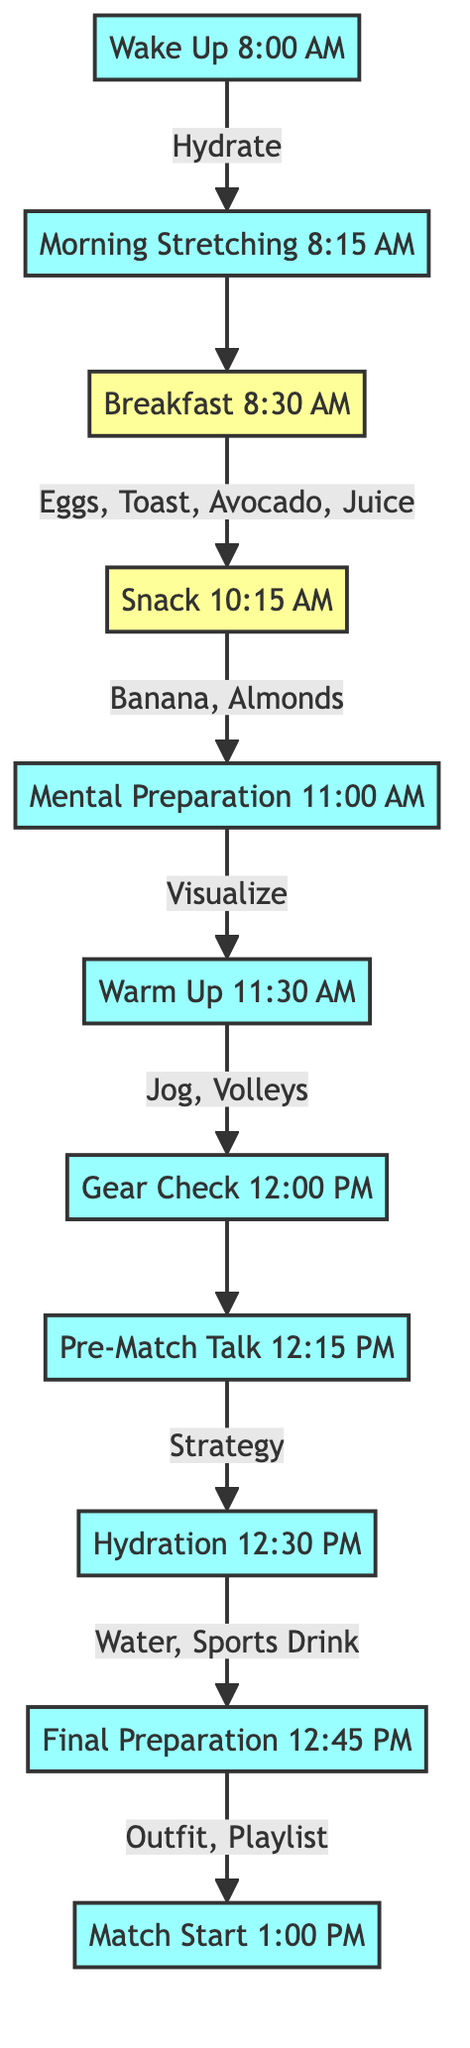What time does the final preparation start? The diagram indicates that the final preparation occurs at 12:45 PM after the hydration step at 12:30 PM.
Answer: 12:45 PM What action is performed at 11:00 AM? The diagram shows that at 11:00 AM, the action is mental preparation, which involves visualization of match scenarios and positive outcomes.
Answer: Mental Preparation How many nutrition components are listed in breakfast? To find this, I look at the breakfast node which lists four components: scrambled eggs, whole grain toast, avocado, and fresh orange juice. Therefore, the count is four.
Answer: 4 What comes after the warm-up action? Following the warm-up at 11:30 AM, the next action listed is the gear check, which starts at 12:00 PM.
Answer: Gear Check What are the components of the snack? In the diagram, the snack at 10:15 AM consists of two components: banana and a handful of almonds.
Answer: Banana, Handful of almonds What is the last action indicated before the match starts? The last action before the match starts is the final preparation taking place at 12:45 PM, which involves putting on the match outfit, warm-up suit, and listening to a motivational playlist.
Answer: Final Preparation At what time is the hydration step performed? The hydration step is specifically listed in the diagram to occur at 12:30 PM.
Answer: 12:30 PM What is the first activity after waking up? After waking up at 8:00 AM, the first activity is morning stretching, which begins at 8:15 AM.
Answer: Morning Stretching What does the pre-match talk focus on? The pre-match talk, which takes place at 12:15 PM, is focused on discussing match strategy with the coach.
Answer: Strategy 